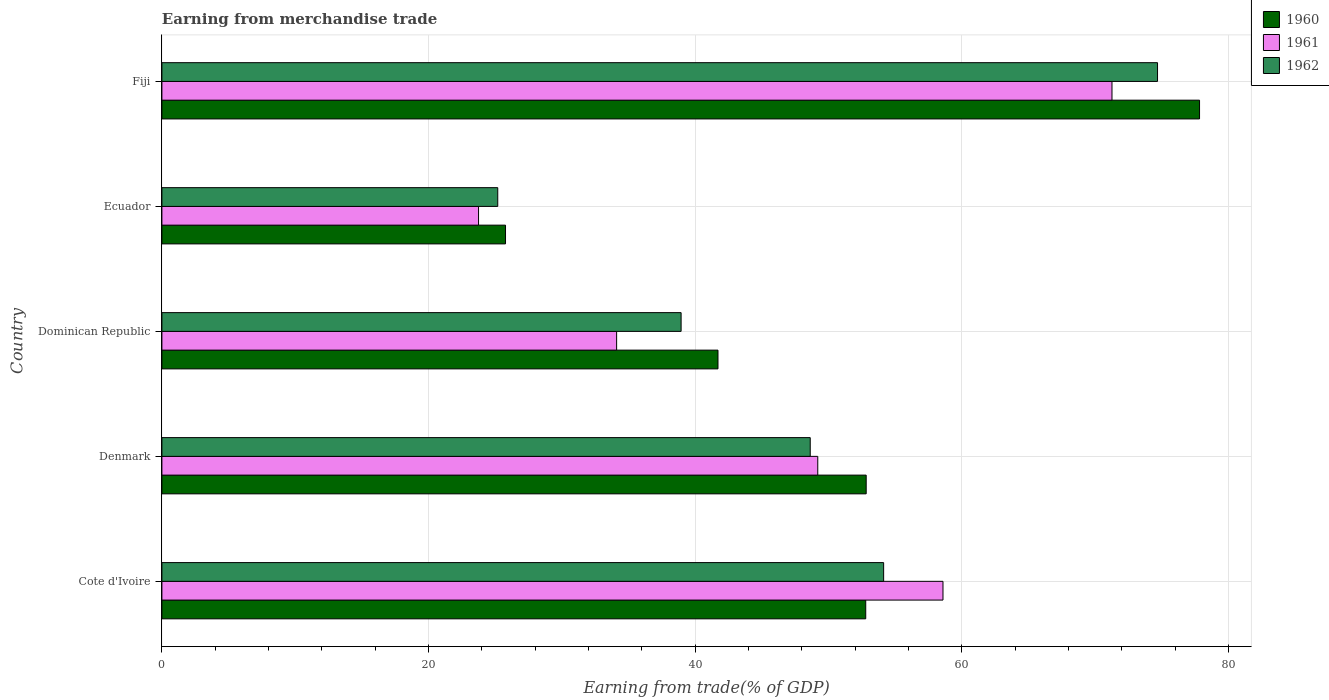How many different coloured bars are there?
Your answer should be very brief. 3. How many groups of bars are there?
Provide a short and direct response. 5. Are the number of bars on each tick of the Y-axis equal?
Keep it short and to the point. Yes. What is the label of the 5th group of bars from the top?
Provide a succinct answer. Cote d'Ivoire. In how many cases, is the number of bars for a given country not equal to the number of legend labels?
Offer a very short reply. 0. What is the earnings from trade in 1961 in Ecuador?
Keep it short and to the point. 23.75. Across all countries, what is the maximum earnings from trade in 1960?
Provide a succinct answer. 77.82. Across all countries, what is the minimum earnings from trade in 1962?
Offer a very short reply. 25.19. In which country was the earnings from trade in 1961 maximum?
Your response must be concise. Fiji. In which country was the earnings from trade in 1961 minimum?
Your answer should be very brief. Ecuador. What is the total earnings from trade in 1960 in the graph?
Your response must be concise. 250.9. What is the difference between the earnings from trade in 1962 in Cote d'Ivoire and that in Ecuador?
Your response must be concise. 28.94. What is the difference between the earnings from trade in 1960 in Fiji and the earnings from trade in 1961 in Dominican Republic?
Provide a succinct answer. 43.72. What is the average earnings from trade in 1962 per country?
Give a very brief answer. 48.31. What is the difference between the earnings from trade in 1960 and earnings from trade in 1962 in Fiji?
Your response must be concise. 3.15. What is the ratio of the earnings from trade in 1960 in Cote d'Ivoire to that in Denmark?
Give a very brief answer. 1. Is the earnings from trade in 1962 in Denmark less than that in Dominican Republic?
Give a very brief answer. No. Is the difference between the earnings from trade in 1960 in Dominican Republic and Fiji greater than the difference between the earnings from trade in 1962 in Dominican Republic and Fiji?
Your answer should be very brief. No. What is the difference between the highest and the second highest earnings from trade in 1960?
Provide a short and direct response. 25. What is the difference between the highest and the lowest earnings from trade in 1960?
Your answer should be very brief. 52.05. In how many countries, is the earnings from trade in 1960 greater than the average earnings from trade in 1960 taken over all countries?
Offer a very short reply. 3. Is the sum of the earnings from trade in 1962 in Cote d'Ivoire and Fiji greater than the maximum earnings from trade in 1961 across all countries?
Your response must be concise. Yes. Are all the bars in the graph horizontal?
Offer a very short reply. Yes. What is the difference between two consecutive major ticks on the X-axis?
Make the answer very short. 20. Where does the legend appear in the graph?
Give a very brief answer. Top right. How are the legend labels stacked?
Your answer should be compact. Vertical. What is the title of the graph?
Your answer should be compact. Earning from merchandise trade. Does "1992" appear as one of the legend labels in the graph?
Make the answer very short. No. What is the label or title of the X-axis?
Keep it short and to the point. Earning from trade(% of GDP). What is the Earning from trade(% of GDP) in 1960 in Cote d'Ivoire?
Offer a terse response. 52.78. What is the Earning from trade(% of GDP) of 1961 in Cote d'Ivoire?
Your answer should be compact. 58.58. What is the Earning from trade(% of GDP) in 1962 in Cote d'Ivoire?
Keep it short and to the point. 54.13. What is the Earning from trade(% of GDP) in 1960 in Denmark?
Offer a terse response. 52.82. What is the Earning from trade(% of GDP) of 1961 in Denmark?
Make the answer very short. 49.19. What is the Earning from trade(% of GDP) in 1962 in Denmark?
Offer a very short reply. 48.62. What is the Earning from trade(% of GDP) of 1960 in Dominican Republic?
Offer a very short reply. 41.7. What is the Earning from trade(% of GDP) of 1961 in Dominican Republic?
Your answer should be very brief. 34.1. What is the Earning from trade(% of GDP) of 1962 in Dominican Republic?
Offer a very short reply. 38.94. What is the Earning from trade(% of GDP) in 1960 in Ecuador?
Your response must be concise. 25.77. What is the Earning from trade(% of GDP) in 1961 in Ecuador?
Offer a terse response. 23.75. What is the Earning from trade(% of GDP) of 1962 in Ecuador?
Your response must be concise. 25.19. What is the Earning from trade(% of GDP) of 1960 in Fiji?
Ensure brevity in your answer.  77.82. What is the Earning from trade(% of GDP) of 1961 in Fiji?
Your response must be concise. 71.25. What is the Earning from trade(% of GDP) in 1962 in Fiji?
Provide a short and direct response. 74.67. Across all countries, what is the maximum Earning from trade(% of GDP) in 1960?
Give a very brief answer. 77.82. Across all countries, what is the maximum Earning from trade(% of GDP) of 1961?
Make the answer very short. 71.25. Across all countries, what is the maximum Earning from trade(% of GDP) of 1962?
Keep it short and to the point. 74.67. Across all countries, what is the minimum Earning from trade(% of GDP) of 1960?
Your answer should be compact. 25.77. Across all countries, what is the minimum Earning from trade(% of GDP) in 1961?
Offer a terse response. 23.75. Across all countries, what is the minimum Earning from trade(% of GDP) in 1962?
Provide a short and direct response. 25.19. What is the total Earning from trade(% of GDP) in 1960 in the graph?
Provide a short and direct response. 250.9. What is the total Earning from trade(% of GDP) of 1961 in the graph?
Provide a succinct answer. 236.87. What is the total Earning from trade(% of GDP) in 1962 in the graph?
Keep it short and to the point. 241.54. What is the difference between the Earning from trade(% of GDP) in 1960 in Cote d'Ivoire and that in Denmark?
Your answer should be compact. -0.04. What is the difference between the Earning from trade(% of GDP) in 1961 in Cote d'Ivoire and that in Denmark?
Keep it short and to the point. 9.39. What is the difference between the Earning from trade(% of GDP) of 1962 in Cote d'Ivoire and that in Denmark?
Offer a very short reply. 5.51. What is the difference between the Earning from trade(% of GDP) in 1960 in Cote d'Ivoire and that in Dominican Republic?
Offer a terse response. 11.08. What is the difference between the Earning from trade(% of GDP) in 1961 in Cote d'Ivoire and that in Dominican Republic?
Keep it short and to the point. 24.48. What is the difference between the Earning from trade(% of GDP) of 1962 in Cote d'Ivoire and that in Dominican Republic?
Make the answer very short. 15.19. What is the difference between the Earning from trade(% of GDP) of 1960 in Cote d'Ivoire and that in Ecuador?
Your answer should be compact. 27.01. What is the difference between the Earning from trade(% of GDP) of 1961 in Cote d'Ivoire and that in Ecuador?
Make the answer very short. 34.83. What is the difference between the Earning from trade(% of GDP) in 1962 in Cote d'Ivoire and that in Ecuador?
Provide a short and direct response. 28.94. What is the difference between the Earning from trade(% of GDP) in 1960 in Cote d'Ivoire and that in Fiji?
Your response must be concise. -25.04. What is the difference between the Earning from trade(% of GDP) of 1961 in Cote d'Ivoire and that in Fiji?
Provide a short and direct response. -12.67. What is the difference between the Earning from trade(% of GDP) of 1962 in Cote d'Ivoire and that in Fiji?
Offer a terse response. -20.54. What is the difference between the Earning from trade(% of GDP) in 1960 in Denmark and that in Dominican Republic?
Make the answer very short. 11.11. What is the difference between the Earning from trade(% of GDP) in 1961 in Denmark and that in Dominican Republic?
Ensure brevity in your answer.  15.08. What is the difference between the Earning from trade(% of GDP) of 1962 in Denmark and that in Dominican Republic?
Offer a terse response. 9.68. What is the difference between the Earning from trade(% of GDP) of 1960 in Denmark and that in Ecuador?
Offer a very short reply. 27.05. What is the difference between the Earning from trade(% of GDP) in 1961 in Denmark and that in Ecuador?
Offer a very short reply. 25.44. What is the difference between the Earning from trade(% of GDP) of 1962 in Denmark and that in Ecuador?
Make the answer very short. 23.44. What is the difference between the Earning from trade(% of GDP) of 1960 in Denmark and that in Fiji?
Give a very brief answer. -25. What is the difference between the Earning from trade(% of GDP) of 1961 in Denmark and that in Fiji?
Offer a terse response. -22.07. What is the difference between the Earning from trade(% of GDP) in 1962 in Denmark and that in Fiji?
Give a very brief answer. -26.05. What is the difference between the Earning from trade(% of GDP) in 1960 in Dominican Republic and that in Ecuador?
Your answer should be very brief. 15.94. What is the difference between the Earning from trade(% of GDP) of 1961 in Dominican Republic and that in Ecuador?
Offer a very short reply. 10.36. What is the difference between the Earning from trade(% of GDP) of 1962 in Dominican Republic and that in Ecuador?
Give a very brief answer. 13.75. What is the difference between the Earning from trade(% of GDP) of 1960 in Dominican Republic and that in Fiji?
Give a very brief answer. -36.12. What is the difference between the Earning from trade(% of GDP) in 1961 in Dominican Republic and that in Fiji?
Give a very brief answer. -37.15. What is the difference between the Earning from trade(% of GDP) of 1962 in Dominican Republic and that in Fiji?
Keep it short and to the point. -35.73. What is the difference between the Earning from trade(% of GDP) of 1960 in Ecuador and that in Fiji?
Provide a succinct answer. -52.05. What is the difference between the Earning from trade(% of GDP) in 1961 in Ecuador and that in Fiji?
Your answer should be very brief. -47.51. What is the difference between the Earning from trade(% of GDP) in 1962 in Ecuador and that in Fiji?
Offer a terse response. -49.48. What is the difference between the Earning from trade(% of GDP) in 1960 in Cote d'Ivoire and the Earning from trade(% of GDP) in 1961 in Denmark?
Give a very brief answer. 3.6. What is the difference between the Earning from trade(% of GDP) of 1960 in Cote d'Ivoire and the Earning from trade(% of GDP) of 1962 in Denmark?
Give a very brief answer. 4.16. What is the difference between the Earning from trade(% of GDP) of 1961 in Cote d'Ivoire and the Earning from trade(% of GDP) of 1962 in Denmark?
Provide a short and direct response. 9.96. What is the difference between the Earning from trade(% of GDP) of 1960 in Cote d'Ivoire and the Earning from trade(% of GDP) of 1961 in Dominican Republic?
Ensure brevity in your answer.  18.68. What is the difference between the Earning from trade(% of GDP) in 1960 in Cote d'Ivoire and the Earning from trade(% of GDP) in 1962 in Dominican Republic?
Keep it short and to the point. 13.85. What is the difference between the Earning from trade(% of GDP) in 1961 in Cote d'Ivoire and the Earning from trade(% of GDP) in 1962 in Dominican Republic?
Keep it short and to the point. 19.64. What is the difference between the Earning from trade(% of GDP) of 1960 in Cote d'Ivoire and the Earning from trade(% of GDP) of 1961 in Ecuador?
Your answer should be compact. 29.04. What is the difference between the Earning from trade(% of GDP) of 1960 in Cote d'Ivoire and the Earning from trade(% of GDP) of 1962 in Ecuador?
Keep it short and to the point. 27.6. What is the difference between the Earning from trade(% of GDP) of 1961 in Cote d'Ivoire and the Earning from trade(% of GDP) of 1962 in Ecuador?
Ensure brevity in your answer.  33.39. What is the difference between the Earning from trade(% of GDP) in 1960 in Cote d'Ivoire and the Earning from trade(% of GDP) in 1961 in Fiji?
Your answer should be very brief. -18.47. What is the difference between the Earning from trade(% of GDP) of 1960 in Cote d'Ivoire and the Earning from trade(% of GDP) of 1962 in Fiji?
Ensure brevity in your answer.  -21.88. What is the difference between the Earning from trade(% of GDP) in 1961 in Cote d'Ivoire and the Earning from trade(% of GDP) in 1962 in Fiji?
Offer a terse response. -16.09. What is the difference between the Earning from trade(% of GDP) of 1960 in Denmark and the Earning from trade(% of GDP) of 1961 in Dominican Republic?
Keep it short and to the point. 18.72. What is the difference between the Earning from trade(% of GDP) of 1960 in Denmark and the Earning from trade(% of GDP) of 1962 in Dominican Republic?
Give a very brief answer. 13.88. What is the difference between the Earning from trade(% of GDP) in 1961 in Denmark and the Earning from trade(% of GDP) in 1962 in Dominican Republic?
Your answer should be compact. 10.25. What is the difference between the Earning from trade(% of GDP) in 1960 in Denmark and the Earning from trade(% of GDP) in 1961 in Ecuador?
Your answer should be very brief. 29.07. What is the difference between the Earning from trade(% of GDP) in 1960 in Denmark and the Earning from trade(% of GDP) in 1962 in Ecuador?
Keep it short and to the point. 27.63. What is the difference between the Earning from trade(% of GDP) of 1961 in Denmark and the Earning from trade(% of GDP) of 1962 in Ecuador?
Provide a succinct answer. 24. What is the difference between the Earning from trade(% of GDP) in 1960 in Denmark and the Earning from trade(% of GDP) in 1961 in Fiji?
Offer a terse response. -18.43. What is the difference between the Earning from trade(% of GDP) in 1960 in Denmark and the Earning from trade(% of GDP) in 1962 in Fiji?
Make the answer very short. -21.85. What is the difference between the Earning from trade(% of GDP) in 1961 in Denmark and the Earning from trade(% of GDP) in 1962 in Fiji?
Your response must be concise. -25.48. What is the difference between the Earning from trade(% of GDP) in 1960 in Dominican Republic and the Earning from trade(% of GDP) in 1961 in Ecuador?
Provide a short and direct response. 17.96. What is the difference between the Earning from trade(% of GDP) in 1960 in Dominican Republic and the Earning from trade(% of GDP) in 1962 in Ecuador?
Provide a short and direct response. 16.52. What is the difference between the Earning from trade(% of GDP) of 1961 in Dominican Republic and the Earning from trade(% of GDP) of 1962 in Ecuador?
Keep it short and to the point. 8.92. What is the difference between the Earning from trade(% of GDP) in 1960 in Dominican Republic and the Earning from trade(% of GDP) in 1961 in Fiji?
Your answer should be compact. -29.55. What is the difference between the Earning from trade(% of GDP) in 1960 in Dominican Republic and the Earning from trade(% of GDP) in 1962 in Fiji?
Provide a short and direct response. -32.96. What is the difference between the Earning from trade(% of GDP) of 1961 in Dominican Republic and the Earning from trade(% of GDP) of 1962 in Fiji?
Offer a very short reply. -40.57. What is the difference between the Earning from trade(% of GDP) of 1960 in Ecuador and the Earning from trade(% of GDP) of 1961 in Fiji?
Provide a succinct answer. -45.48. What is the difference between the Earning from trade(% of GDP) in 1960 in Ecuador and the Earning from trade(% of GDP) in 1962 in Fiji?
Give a very brief answer. -48.9. What is the difference between the Earning from trade(% of GDP) in 1961 in Ecuador and the Earning from trade(% of GDP) in 1962 in Fiji?
Make the answer very short. -50.92. What is the average Earning from trade(% of GDP) in 1960 per country?
Keep it short and to the point. 50.18. What is the average Earning from trade(% of GDP) in 1961 per country?
Provide a short and direct response. 47.37. What is the average Earning from trade(% of GDP) in 1962 per country?
Keep it short and to the point. 48.31. What is the difference between the Earning from trade(% of GDP) of 1960 and Earning from trade(% of GDP) of 1961 in Cote d'Ivoire?
Your answer should be compact. -5.79. What is the difference between the Earning from trade(% of GDP) of 1960 and Earning from trade(% of GDP) of 1962 in Cote d'Ivoire?
Your response must be concise. -1.34. What is the difference between the Earning from trade(% of GDP) in 1961 and Earning from trade(% of GDP) in 1962 in Cote d'Ivoire?
Offer a very short reply. 4.45. What is the difference between the Earning from trade(% of GDP) in 1960 and Earning from trade(% of GDP) in 1961 in Denmark?
Keep it short and to the point. 3.63. What is the difference between the Earning from trade(% of GDP) of 1960 and Earning from trade(% of GDP) of 1962 in Denmark?
Your answer should be compact. 4.2. What is the difference between the Earning from trade(% of GDP) in 1961 and Earning from trade(% of GDP) in 1962 in Denmark?
Your response must be concise. 0.56. What is the difference between the Earning from trade(% of GDP) in 1960 and Earning from trade(% of GDP) in 1961 in Dominican Republic?
Make the answer very short. 7.6. What is the difference between the Earning from trade(% of GDP) of 1960 and Earning from trade(% of GDP) of 1962 in Dominican Republic?
Offer a terse response. 2.77. What is the difference between the Earning from trade(% of GDP) of 1961 and Earning from trade(% of GDP) of 1962 in Dominican Republic?
Your response must be concise. -4.84. What is the difference between the Earning from trade(% of GDP) in 1960 and Earning from trade(% of GDP) in 1961 in Ecuador?
Ensure brevity in your answer.  2.02. What is the difference between the Earning from trade(% of GDP) of 1960 and Earning from trade(% of GDP) of 1962 in Ecuador?
Ensure brevity in your answer.  0.58. What is the difference between the Earning from trade(% of GDP) of 1961 and Earning from trade(% of GDP) of 1962 in Ecuador?
Provide a short and direct response. -1.44. What is the difference between the Earning from trade(% of GDP) in 1960 and Earning from trade(% of GDP) in 1961 in Fiji?
Your answer should be compact. 6.57. What is the difference between the Earning from trade(% of GDP) of 1960 and Earning from trade(% of GDP) of 1962 in Fiji?
Your answer should be very brief. 3.15. What is the difference between the Earning from trade(% of GDP) of 1961 and Earning from trade(% of GDP) of 1962 in Fiji?
Your answer should be compact. -3.42. What is the ratio of the Earning from trade(% of GDP) in 1960 in Cote d'Ivoire to that in Denmark?
Your answer should be very brief. 1. What is the ratio of the Earning from trade(% of GDP) of 1961 in Cote d'Ivoire to that in Denmark?
Give a very brief answer. 1.19. What is the ratio of the Earning from trade(% of GDP) in 1962 in Cote d'Ivoire to that in Denmark?
Your answer should be compact. 1.11. What is the ratio of the Earning from trade(% of GDP) in 1960 in Cote d'Ivoire to that in Dominican Republic?
Give a very brief answer. 1.27. What is the ratio of the Earning from trade(% of GDP) in 1961 in Cote d'Ivoire to that in Dominican Republic?
Offer a very short reply. 1.72. What is the ratio of the Earning from trade(% of GDP) of 1962 in Cote d'Ivoire to that in Dominican Republic?
Make the answer very short. 1.39. What is the ratio of the Earning from trade(% of GDP) in 1960 in Cote d'Ivoire to that in Ecuador?
Your answer should be very brief. 2.05. What is the ratio of the Earning from trade(% of GDP) of 1961 in Cote d'Ivoire to that in Ecuador?
Your answer should be very brief. 2.47. What is the ratio of the Earning from trade(% of GDP) in 1962 in Cote d'Ivoire to that in Ecuador?
Your answer should be very brief. 2.15. What is the ratio of the Earning from trade(% of GDP) in 1960 in Cote d'Ivoire to that in Fiji?
Ensure brevity in your answer.  0.68. What is the ratio of the Earning from trade(% of GDP) of 1961 in Cote d'Ivoire to that in Fiji?
Your answer should be compact. 0.82. What is the ratio of the Earning from trade(% of GDP) in 1962 in Cote d'Ivoire to that in Fiji?
Provide a succinct answer. 0.72. What is the ratio of the Earning from trade(% of GDP) of 1960 in Denmark to that in Dominican Republic?
Offer a very short reply. 1.27. What is the ratio of the Earning from trade(% of GDP) in 1961 in Denmark to that in Dominican Republic?
Your answer should be very brief. 1.44. What is the ratio of the Earning from trade(% of GDP) of 1962 in Denmark to that in Dominican Republic?
Keep it short and to the point. 1.25. What is the ratio of the Earning from trade(% of GDP) in 1960 in Denmark to that in Ecuador?
Your answer should be compact. 2.05. What is the ratio of the Earning from trade(% of GDP) of 1961 in Denmark to that in Ecuador?
Offer a terse response. 2.07. What is the ratio of the Earning from trade(% of GDP) of 1962 in Denmark to that in Ecuador?
Make the answer very short. 1.93. What is the ratio of the Earning from trade(% of GDP) of 1960 in Denmark to that in Fiji?
Provide a succinct answer. 0.68. What is the ratio of the Earning from trade(% of GDP) in 1961 in Denmark to that in Fiji?
Your answer should be very brief. 0.69. What is the ratio of the Earning from trade(% of GDP) in 1962 in Denmark to that in Fiji?
Provide a succinct answer. 0.65. What is the ratio of the Earning from trade(% of GDP) of 1960 in Dominican Republic to that in Ecuador?
Offer a terse response. 1.62. What is the ratio of the Earning from trade(% of GDP) in 1961 in Dominican Republic to that in Ecuador?
Provide a succinct answer. 1.44. What is the ratio of the Earning from trade(% of GDP) of 1962 in Dominican Republic to that in Ecuador?
Your answer should be compact. 1.55. What is the ratio of the Earning from trade(% of GDP) of 1960 in Dominican Republic to that in Fiji?
Your answer should be very brief. 0.54. What is the ratio of the Earning from trade(% of GDP) of 1961 in Dominican Republic to that in Fiji?
Your response must be concise. 0.48. What is the ratio of the Earning from trade(% of GDP) of 1962 in Dominican Republic to that in Fiji?
Offer a very short reply. 0.52. What is the ratio of the Earning from trade(% of GDP) in 1960 in Ecuador to that in Fiji?
Ensure brevity in your answer.  0.33. What is the ratio of the Earning from trade(% of GDP) in 1962 in Ecuador to that in Fiji?
Give a very brief answer. 0.34. What is the difference between the highest and the second highest Earning from trade(% of GDP) in 1960?
Your answer should be very brief. 25. What is the difference between the highest and the second highest Earning from trade(% of GDP) in 1961?
Provide a short and direct response. 12.67. What is the difference between the highest and the second highest Earning from trade(% of GDP) of 1962?
Provide a short and direct response. 20.54. What is the difference between the highest and the lowest Earning from trade(% of GDP) in 1960?
Provide a succinct answer. 52.05. What is the difference between the highest and the lowest Earning from trade(% of GDP) of 1961?
Your answer should be compact. 47.51. What is the difference between the highest and the lowest Earning from trade(% of GDP) of 1962?
Your response must be concise. 49.48. 